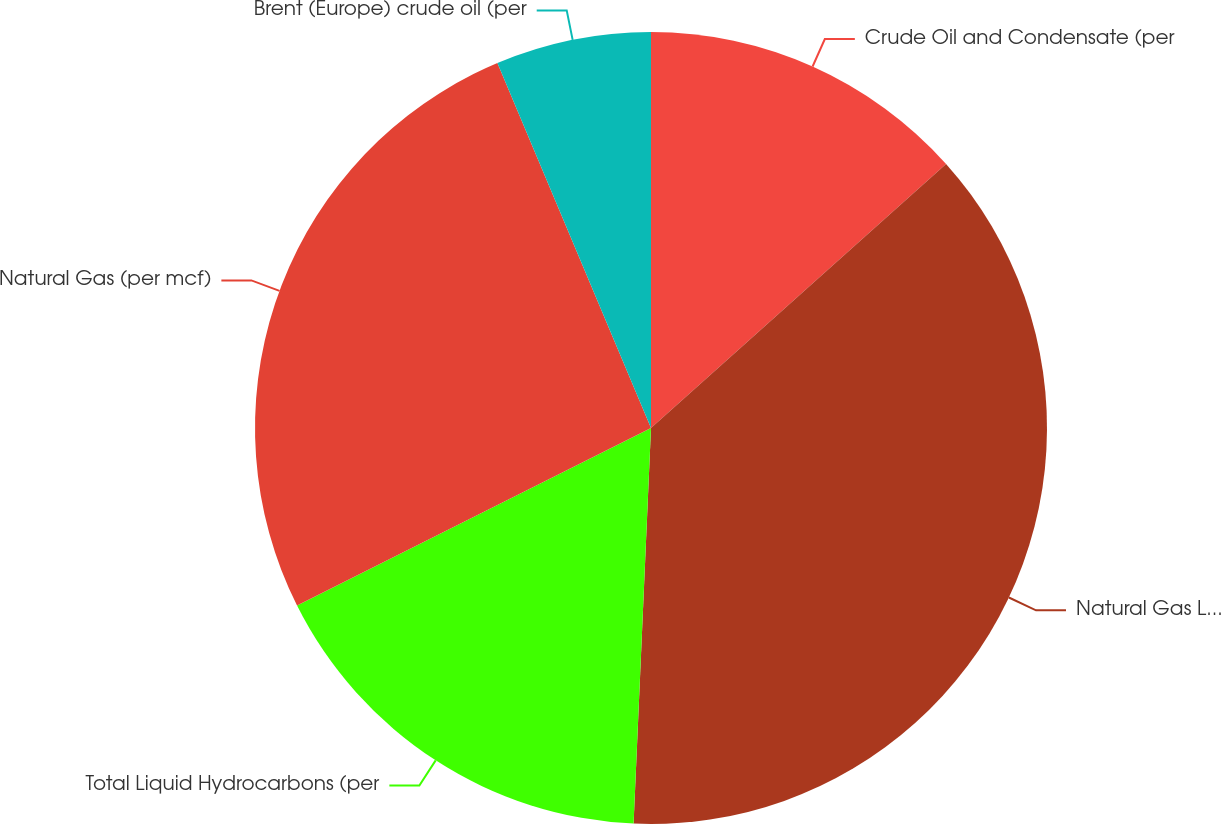Convert chart. <chart><loc_0><loc_0><loc_500><loc_500><pie_chart><fcel>Crude Oil and Condensate (per<fcel>Natural Gas Liquids (per bbl)<fcel>Total Liquid Hydrocarbons (per<fcel>Natural Gas (per mcf)<fcel>Brent (Europe) crude oil (per<nl><fcel>13.38%<fcel>37.32%<fcel>16.9%<fcel>26.06%<fcel>6.34%<nl></chart> 